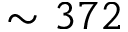Convert formula to latex. <formula><loc_0><loc_0><loc_500><loc_500>\sim 3 7 2</formula> 